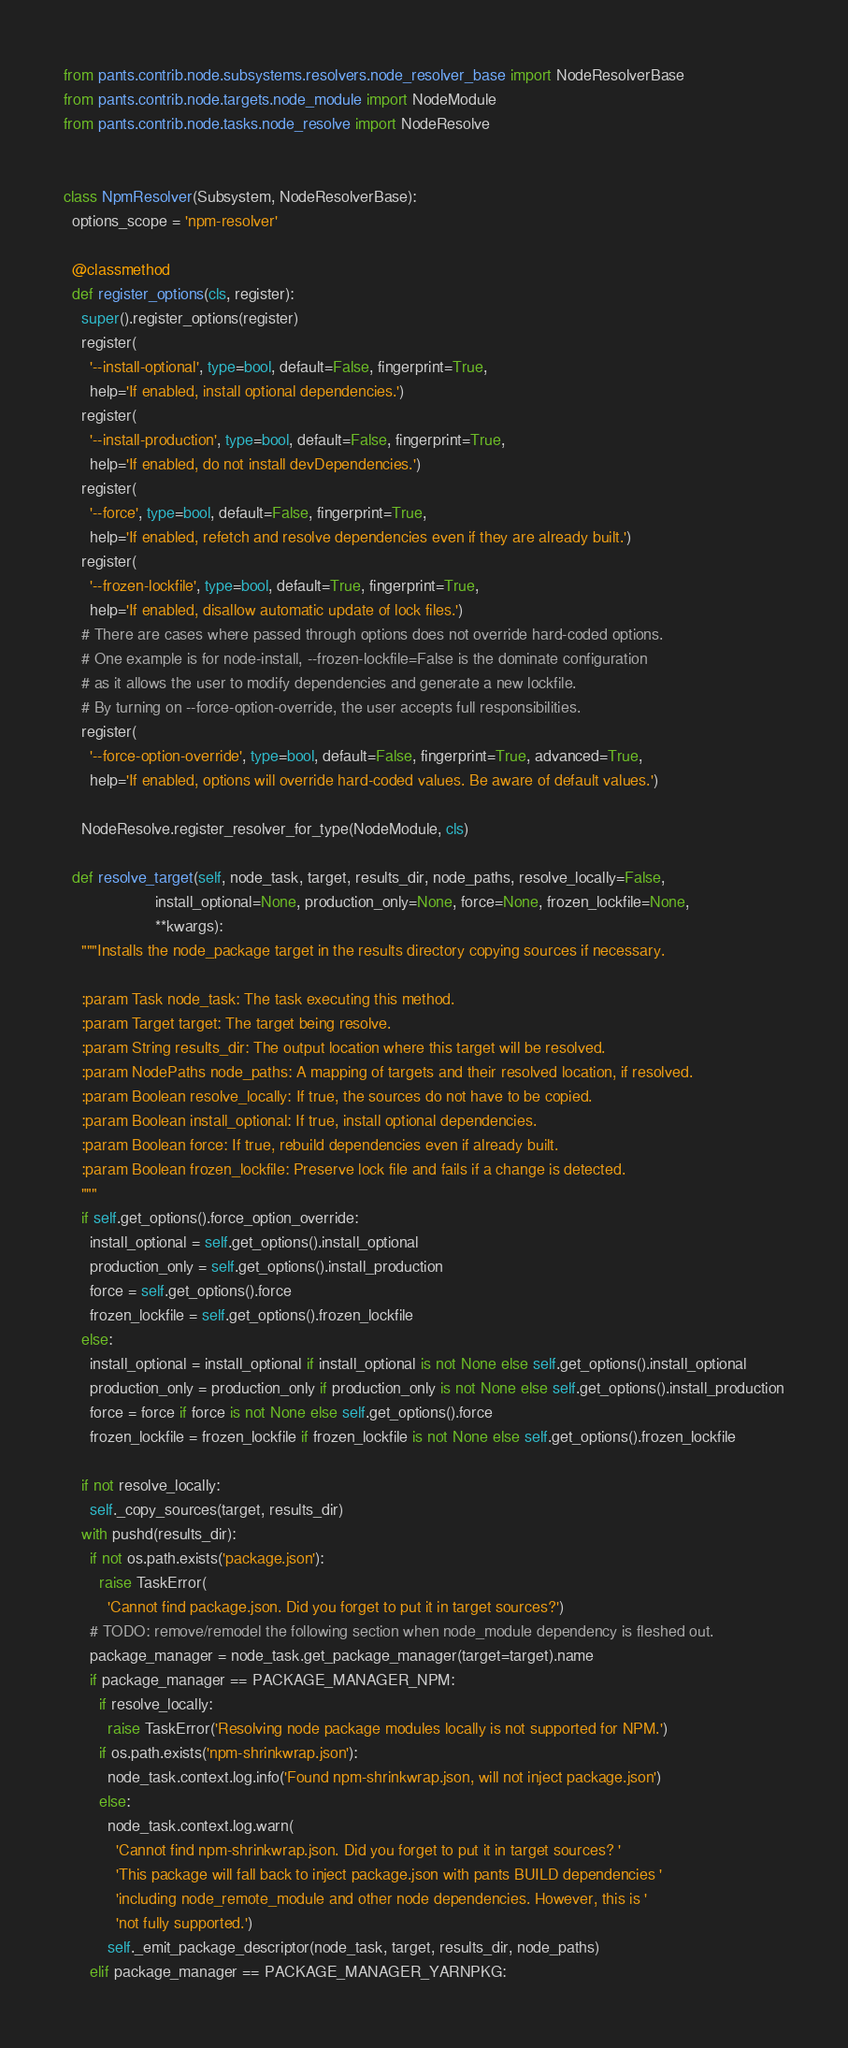<code> <loc_0><loc_0><loc_500><loc_500><_Python_>from pants.contrib.node.subsystems.resolvers.node_resolver_base import NodeResolverBase
from pants.contrib.node.targets.node_module import NodeModule
from pants.contrib.node.tasks.node_resolve import NodeResolve


class NpmResolver(Subsystem, NodeResolverBase):
  options_scope = 'npm-resolver'

  @classmethod
  def register_options(cls, register):
    super().register_options(register)
    register(
      '--install-optional', type=bool, default=False, fingerprint=True,
      help='If enabled, install optional dependencies.')
    register(
      '--install-production', type=bool, default=False, fingerprint=True,
      help='If enabled, do not install devDependencies.')
    register(
      '--force', type=bool, default=False, fingerprint=True,
      help='If enabled, refetch and resolve dependencies even if they are already built.')
    register(
      '--frozen-lockfile', type=bool, default=True, fingerprint=True,
      help='If enabled, disallow automatic update of lock files.')
    # There are cases where passed through options does not override hard-coded options.
    # One example is for node-install, --frozen-lockfile=False is the dominate configuration
    # as it allows the user to modify dependencies and generate a new lockfile.
    # By turning on --force-option-override, the user accepts full responsibilities.
    register(
      '--force-option-override', type=bool, default=False, fingerprint=True, advanced=True,
      help='If enabled, options will override hard-coded values. Be aware of default values.')

    NodeResolve.register_resolver_for_type(NodeModule, cls)

  def resolve_target(self, node_task, target, results_dir, node_paths, resolve_locally=False,
                     install_optional=None, production_only=None, force=None, frozen_lockfile=None,
                     **kwargs):
    """Installs the node_package target in the results directory copying sources if necessary.

    :param Task node_task: The task executing this method.
    :param Target target: The target being resolve.
    :param String results_dir: The output location where this target will be resolved.
    :param NodePaths node_paths: A mapping of targets and their resolved location, if resolved.
    :param Boolean resolve_locally: If true, the sources do not have to be copied.
    :param Boolean install_optional: If true, install optional dependencies.
    :param Boolean force: If true, rebuild dependencies even if already built.
    :param Boolean frozen_lockfile: Preserve lock file and fails if a change is detected.
    """
    if self.get_options().force_option_override:
      install_optional = self.get_options().install_optional
      production_only = self.get_options().install_production
      force = self.get_options().force
      frozen_lockfile = self.get_options().frozen_lockfile
    else:
      install_optional = install_optional if install_optional is not None else self.get_options().install_optional
      production_only = production_only if production_only is not None else self.get_options().install_production
      force = force if force is not None else self.get_options().force
      frozen_lockfile = frozen_lockfile if frozen_lockfile is not None else self.get_options().frozen_lockfile

    if not resolve_locally:
      self._copy_sources(target, results_dir)
    with pushd(results_dir):
      if not os.path.exists('package.json'):
        raise TaskError(
          'Cannot find package.json. Did you forget to put it in target sources?')
      # TODO: remove/remodel the following section when node_module dependency is fleshed out.
      package_manager = node_task.get_package_manager(target=target).name
      if package_manager == PACKAGE_MANAGER_NPM:
        if resolve_locally:
          raise TaskError('Resolving node package modules locally is not supported for NPM.')
        if os.path.exists('npm-shrinkwrap.json'):
          node_task.context.log.info('Found npm-shrinkwrap.json, will not inject package.json')
        else:
          node_task.context.log.warn(
            'Cannot find npm-shrinkwrap.json. Did you forget to put it in target sources? '
            'This package will fall back to inject package.json with pants BUILD dependencies '
            'including node_remote_module and other node dependencies. However, this is '
            'not fully supported.')
          self._emit_package_descriptor(node_task, target, results_dir, node_paths)
      elif package_manager == PACKAGE_MANAGER_YARNPKG:</code> 